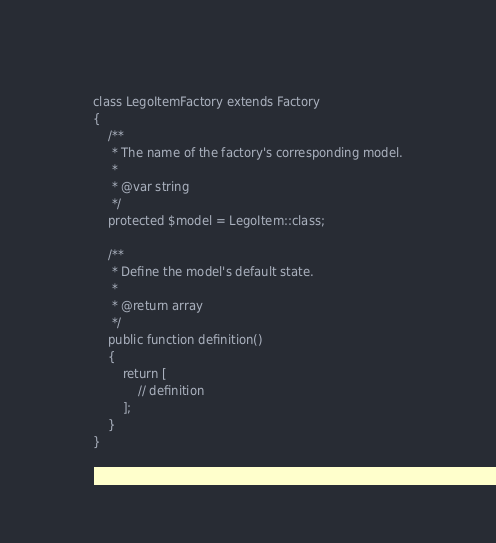Convert code to text. <code><loc_0><loc_0><loc_500><loc_500><_PHP_>
class LegoItemFactory extends Factory
{
    /**
     * The name of the factory's corresponding model.
     *
     * @var string
     */
    protected $model = LegoItem::class;

    /**
     * Define the model's default state.
     *
     * @return array
     */
    public function definition()
    {
        return [
            // definition
        ];
    }
}
</code> 